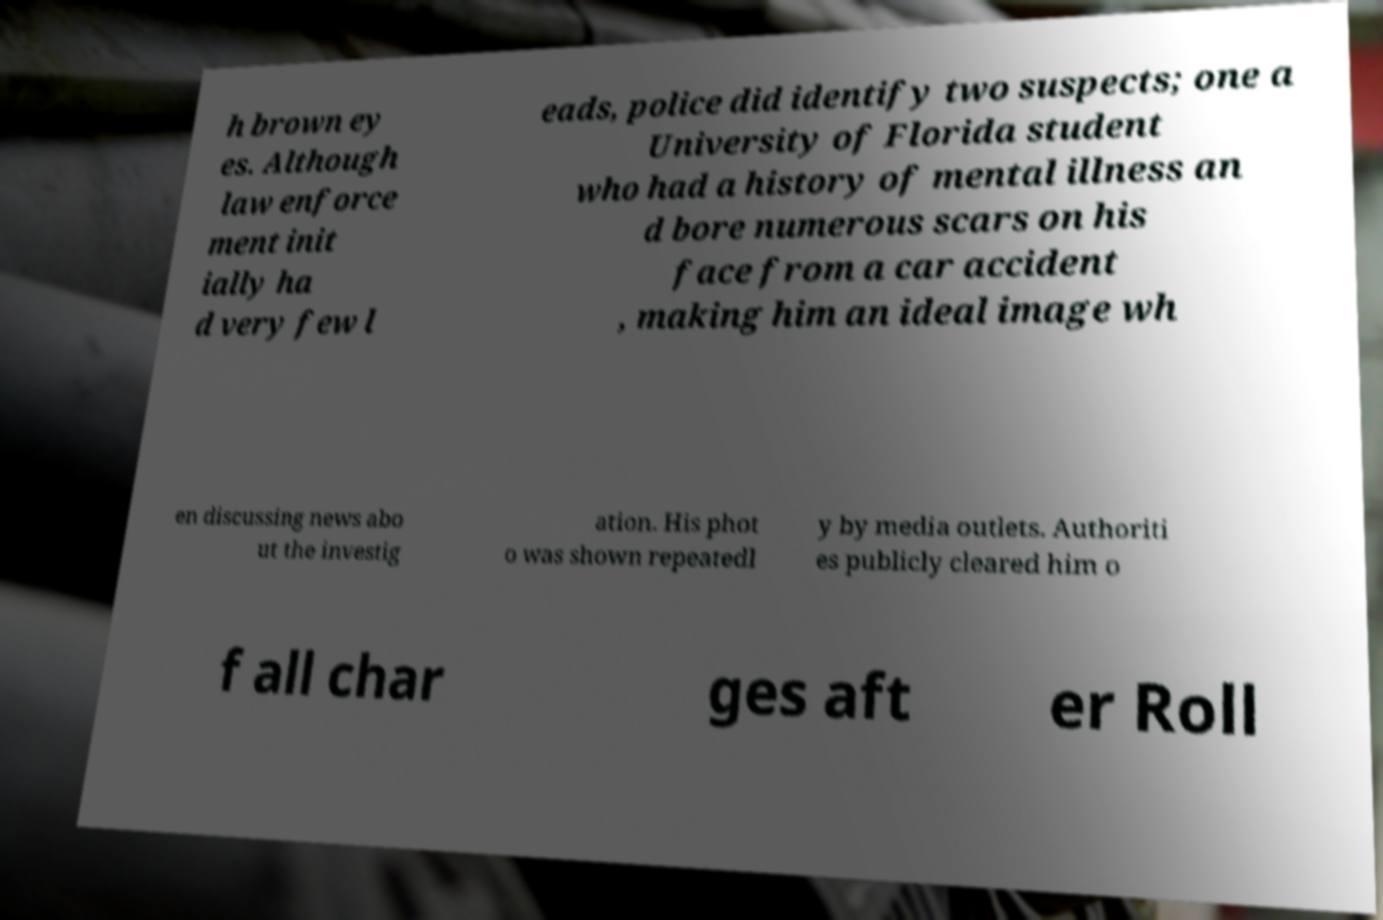Please read and relay the text visible in this image. What does it say? h brown ey es. Although law enforce ment init ially ha d very few l eads, police did identify two suspects; one a University of Florida student who had a history of mental illness an d bore numerous scars on his face from a car accident , making him an ideal image wh en discussing news abo ut the investig ation. His phot o was shown repeatedl y by media outlets. Authoriti es publicly cleared him o f all char ges aft er Roll 